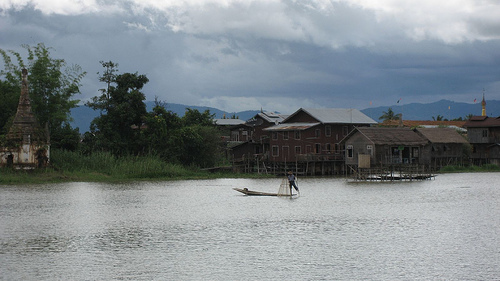<image>
Can you confirm if the man is above the river? Yes. The man is positioned above the river in the vertical space, higher up in the scene. 